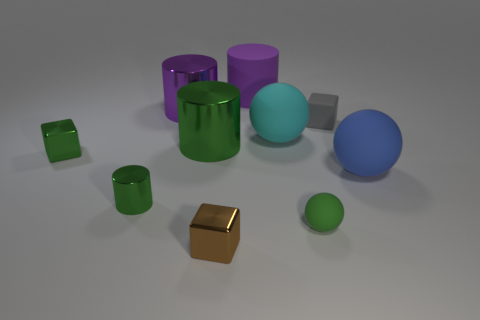Subtract all blue spheres. How many green cylinders are left? 2 Subtract all big blue rubber spheres. How many spheres are left? 2 Subtract 1 blocks. How many blocks are left? 2 Subtract all spheres. How many objects are left? 7 Subtract all brown spheres. Subtract all purple cylinders. How many spheres are left? 3 Add 2 small gray blocks. How many small gray blocks are left? 3 Add 8 small brown matte cubes. How many small brown matte cubes exist? 8 Subtract 0 purple cubes. How many objects are left? 10 Subtract all large rubber things. Subtract all large green shiny cylinders. How many objects are left? 6 